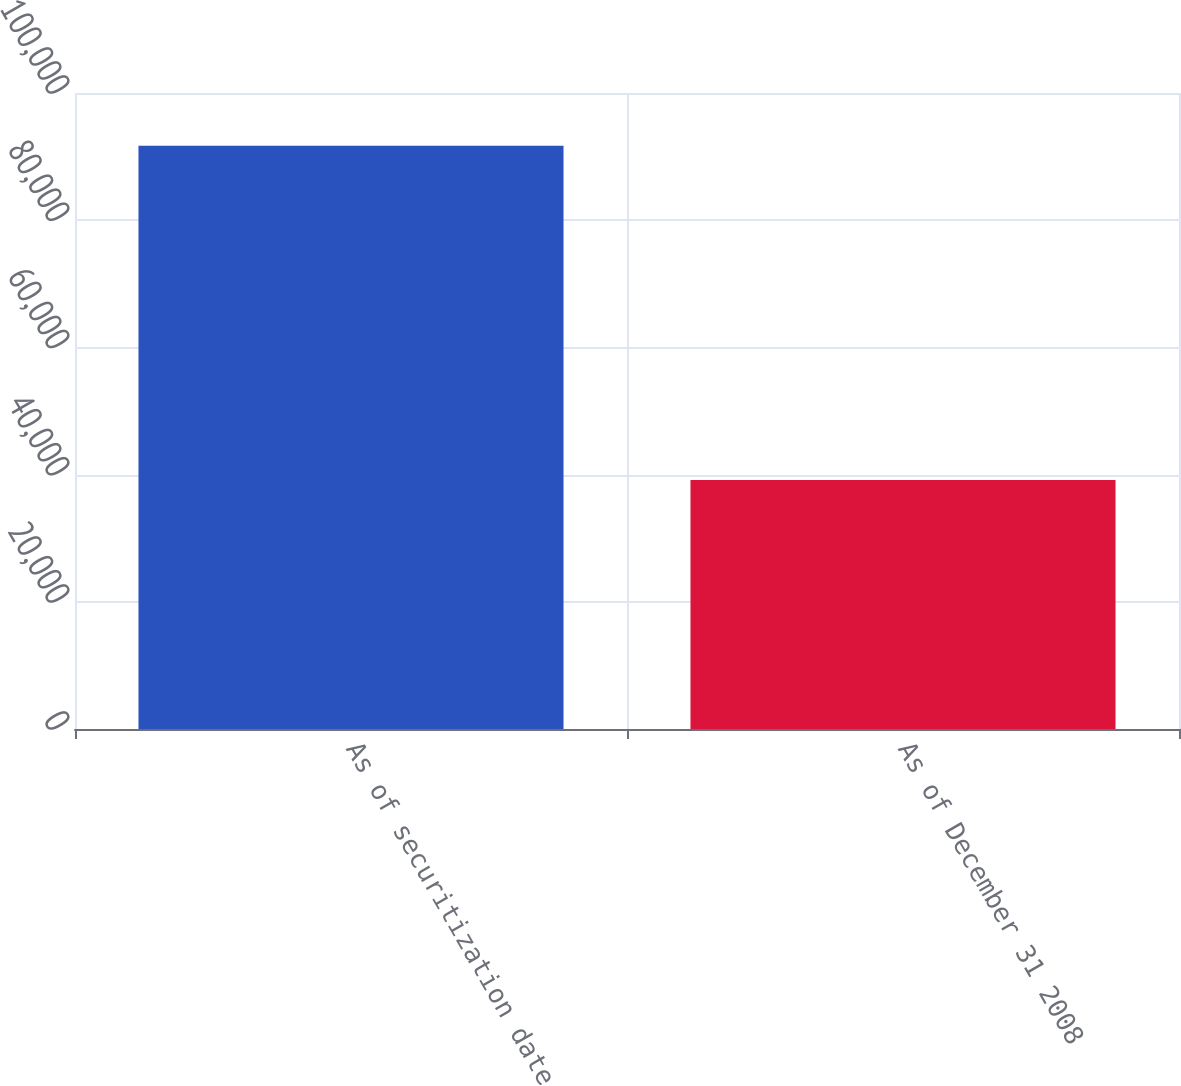Convert chart to OTSL. <chart><loc_0><loc_0><loc_500><loc_500><bar_chart><fcel>As of securitization date<fcel>As of December 31 2008<nl><fcel>91705<fcel>39155<nl></chart> 